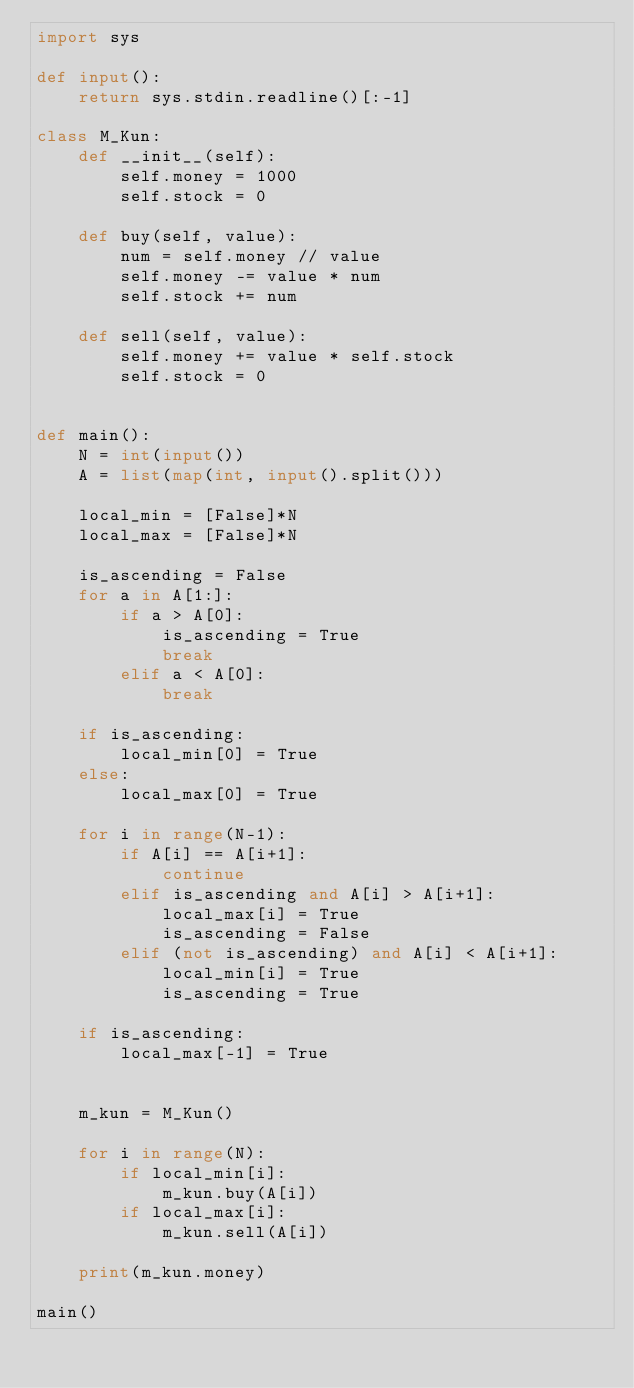<code> <loc_0><loc_0><loc_500><loc_500><_Python_>import sys

def input():
    return sys.stdin.readline()[:-1]

class M_Kun:
    def __init__(self):
        self.money = 1000
        self.stock = 0
        
    def buy(self, value):
        num = self.money // value
        self.money -= value * num
        self.stock += num
        
    def sell(self, value):
        self.money += value * self.stock
        self.stock = 0


def main():
    N = int(input())
    A = list(map(int, input().split()))

    local_min = [False]*N
    local_max = [False]*N

    is_ascending = False
    for a in A[1:]:
        if a > A[0]:
            is_ascending = True
            break
        elif a < A[0]:
            break

    if is_ascending:
        local_min[0] = True
    else:
        local_max[0] = True

    for i in range(N-1):
        if A[i] == A[i+1]:
            continue
        elif is_ascending and A[i] > A[i+1]:
            local_max[i] = True
            is_ascending = False
        elif (not is_ascending) and A[i] < A[i+1]:
            local_min[i] = True
            is_ascending = True

    if is_ascending:
        local_max[-1] = True


    m_kun = M_Kun()

    for i in range(N):
        if local_min[i]:
            m_kun.buy(A[i])
        if local_max[i]:
            m_kun.sell(A[i])

    print(m_kun.money)
    
main()</code> 